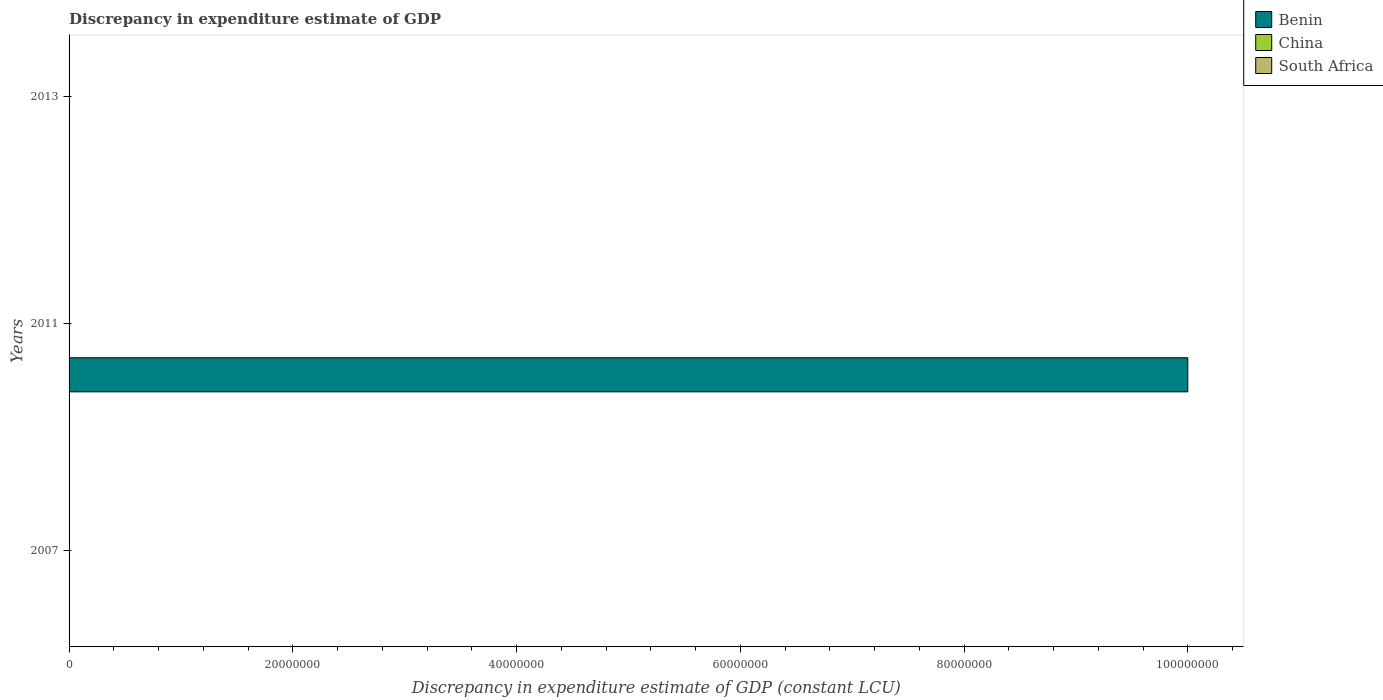How many different coloured bars are there?
Your answer should be very brief. 1. How many bars are there on the 2nd tick from the top?
Your answer should be compact. 1. In how many cases, is the number of bars for a given year not equal to the number of legend labels?
Keep it short and to the point. 3. Across all years, what is the maximum discrepancy in expenditure estimate of GDP in Benin?
Make the answer very short. 1.00e+08. Across all years, what is the minimum discrepancy in expenditure estimate of GDP in Benin?
Give a very brief answer. 0. What is the difference between the discrepancy in expenditure estimate of GDP in Benin in 2007 and that in 2011?
Offer a very short reply. -1.00e+08. What is the ratio of the discrepancy in expenditure estimate of GDP in Benin in 2007 to that in 2011?
Provide a succinct answer. 1e-6. In how many years, is the discrepancy in expenditure estimate of GDP in China greater than the average discrepancy in expenditure estimate of GDP in China taken over all years?
Offer a very short reply. 0. How many bars are there?
Offer a very short reply. 2. Are the values on the major ticks of X-axis written in scientific E-notation?
Your answer should be compact. No. Does the graph contain grids?
Offer a terse response. No. Where does the legend appear in the graph?
Your answer should be compact. Top right. How are the legend labels stacked?
Provide a succinct answer. Vertical. What is the title of the graph?
Provide a succinct answer. Discrepancy in expenditure estimate of GDP. What is the label or title of the X-axis?
Your answer should be compact. Discrepancy in expenditure estimate of GDP (constant LCU). What is the Discrepancy in expenditure estimate of GDP (constant LCU) in China in 2007?
Keep it short and to the point. 0. What is the Discrepancy in expenditure estimate of GDP (constant LCU) in Benin in 2011?
Keep it short and to the point. 1.00e+08. What is the Discrepancy in expenditure estimate of GDP (constant LCU) in China in 2011?
Your answer should be very brief. 0. What is the Discrepancy in expenditure estimate of GDP (constant LCU) in China in 2013?
Make the answer very short. 0. Across all years, what is the minimum Discrepancy in expenditure estimate of GDP (constant LCU) in Benin?
Offer a terse response. 0. What is the total Discrepancy in expenditure estimate of GDP (constant LCU) in Benin in the graph?
Make the answer very short. 1.00e+08. What is the total Discrepancy in expenditure estimate of GDP (constant LCU) of South Africa in the graph?
Make the answer very short. 0. What is the difference between the Discrepancy in expenditure estimate of GDP (constant LCU) of Benin in 2007 and that in 2011?
Give a very brief answer. -1.00e+08. What is the average Discrepancy in expenditure estimate of GDP (constant LCU) of Benin per year?
Provide a short and direct response. 3.33e+07. What is the average Discrepancy in expenditure estimate of GDP (constant LCU) in South Africa per year?
Your answer should be compact. 0. What is the ratio of the Discrepancy in expenditure estimate of GDP (constant LCU) of Benin in 2007 to that in 2011?
Provide a succinct answer. 0. What is the difference between the highest and the lowest Discrepancy in expenditure estimate of GDP (constant LCU) of Benin?
Ensure brevity in your answer.  1.00e+08. 